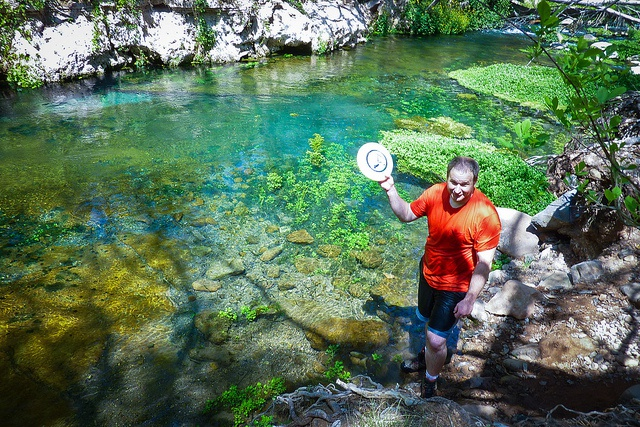Describe the objects in this image and their specific colors. I can see people in gray, black, maroon, and red tones and frisbee in gray, white, darkgray, and teal tones in this image. 